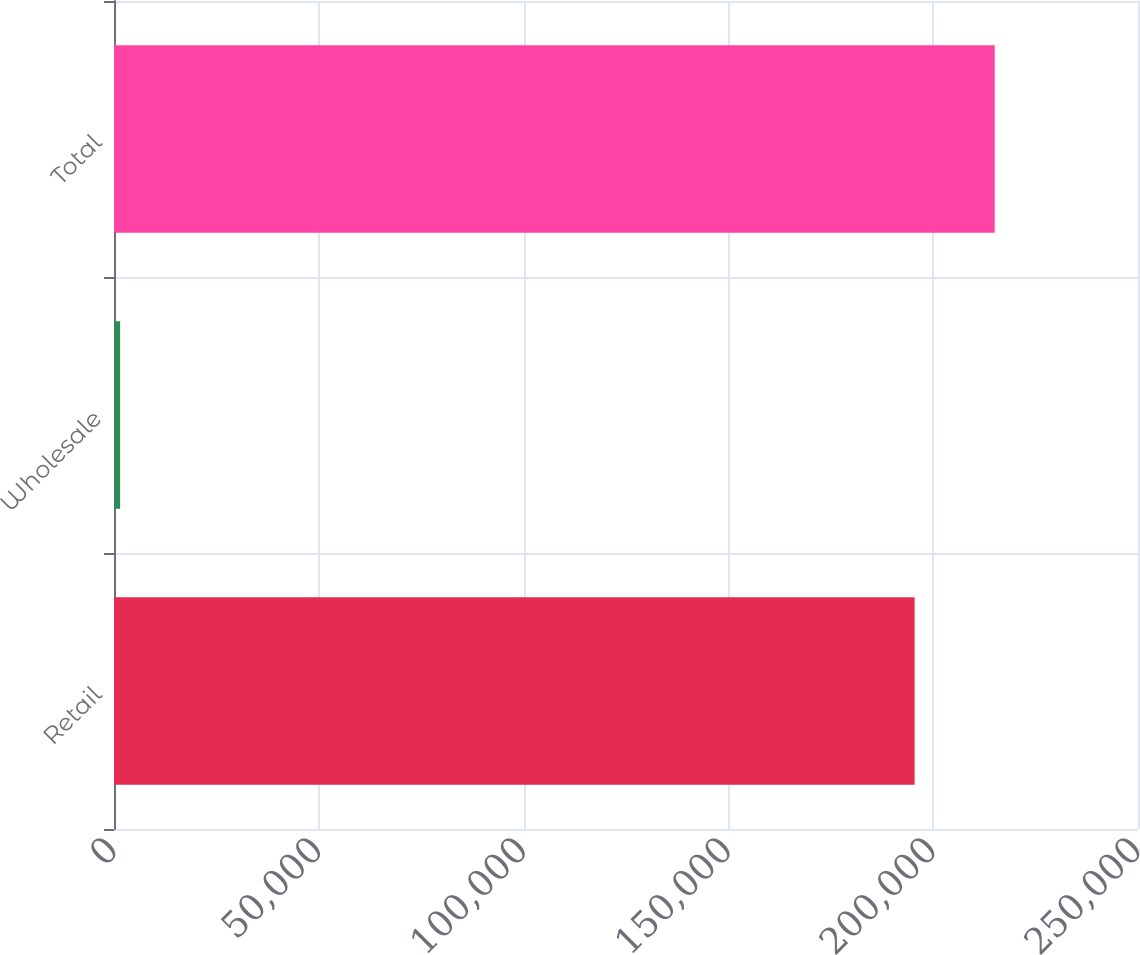Convert chart to OTSL. <chart><loc_0><loc_0><loc_500><loc_500><bar_chart><fcel>Retail<fcel>Wholesale<fcel>Total<nl><fcel>195468<fcel>1495<fcel>215015<nl></chart> 